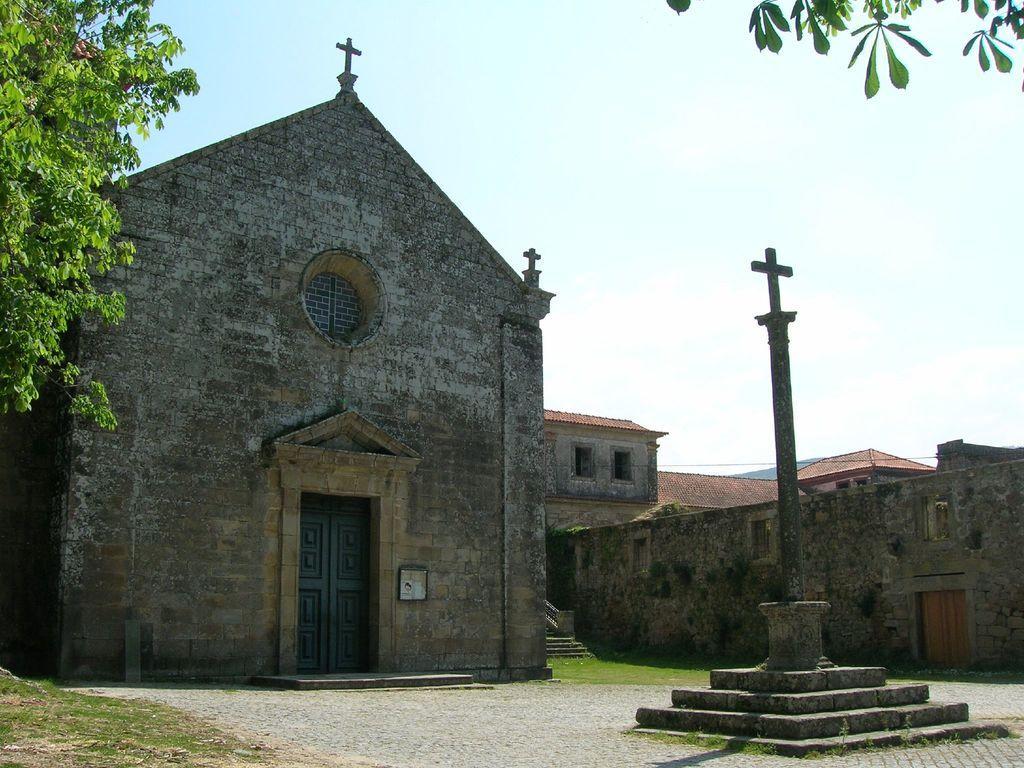Please provide a concise description of this image. I think this is a church. I can see the holy cross symbols at the top of the building. This looks like a window. I think this is a door. This looks like a pole. These are the stairs. I think these are the houses. I can see a wooden door. Here is the tree. 